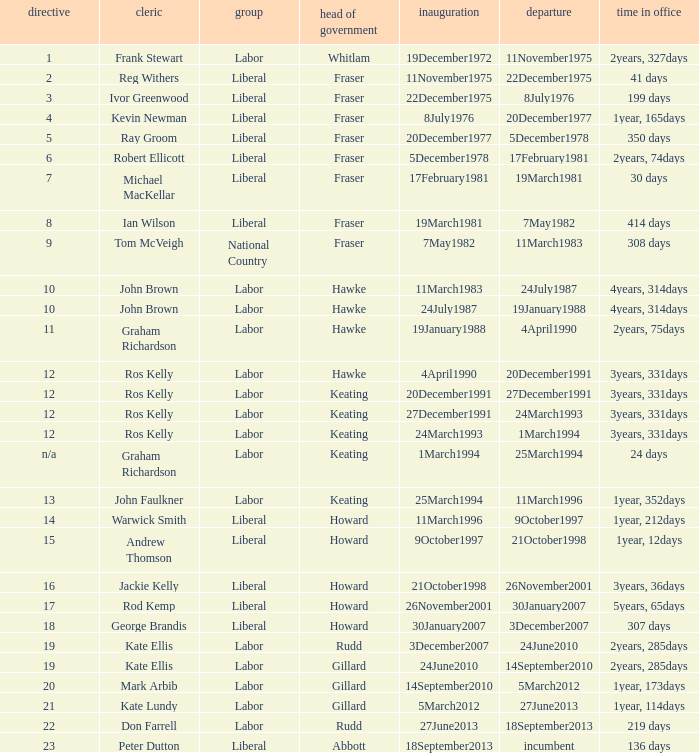What is the Term in office with an Order that is 9? 308 days. 